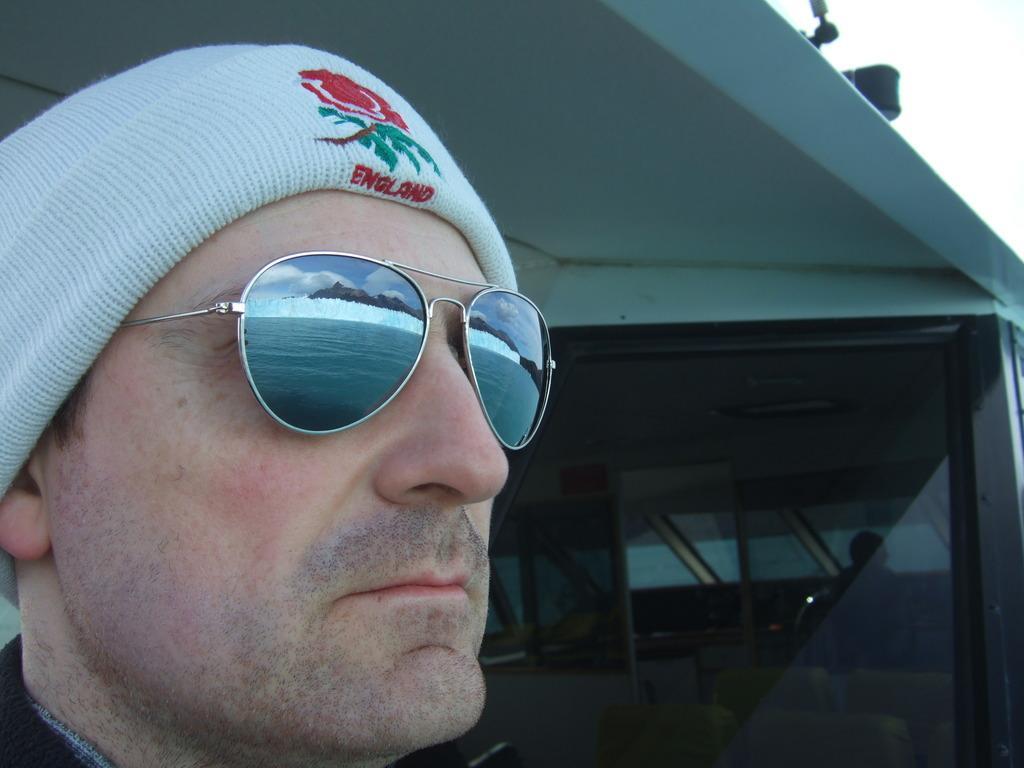Please provide a concise description of this image. This picture shows a man. He wore sunglasses on his face and a cap on his head, It is white in color and we see a glass window. 